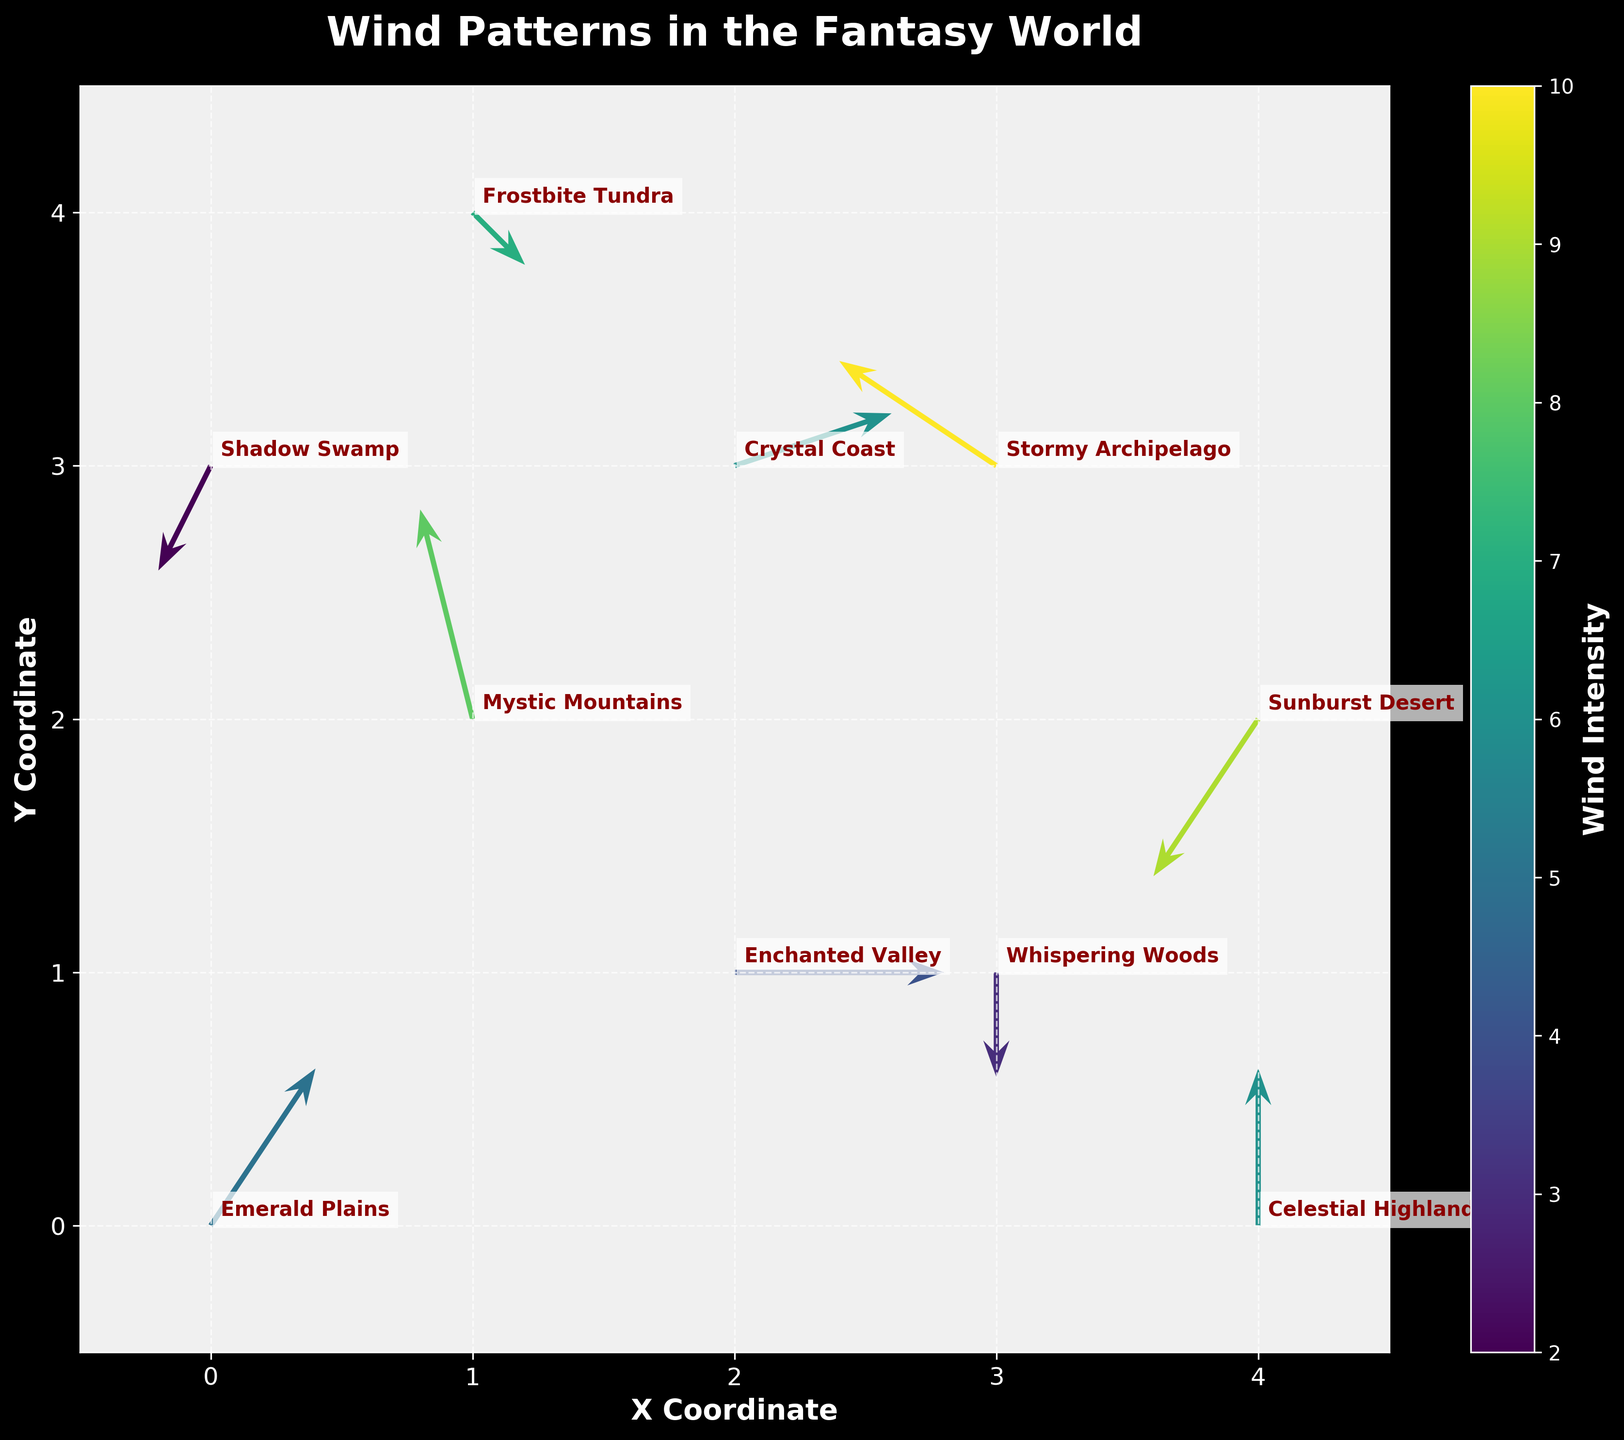Which region shows the highest wind intensity? The region with the highest wind intensity is indicated by the darkest color on the quiver plot. By observing the color gradient, Stormy Archipelago has the highest intensity of 10.
Answer: Stormy Archipelago How many data points are plotted in total? Counting the quivers on the plot, there are 10 data points representing the regions listed in the provided data.
Answer: 10 Which region has the wind direction going directly downward? The wind direction going directly downward is represented by a quiver with a vertical component (v) and no horizontal component (u). Whispering Woods has this characteristic with (0, -2).
Answer: Whispering Woods What is the average wind intensity across all regions? By summing the wind intensities (5 + 8 + 3 + 6 + 9 + 7 + 10 + 4 + 6 + 2) and then dividing by the number of regions (10), the average intensity is calculated as (60 / 10) = 6.
Answer: 6 Which regions have wind intensities greater than 6? By examining the color bar and region labels, the regions with wind intensities greater than 6 are Mystic Mountains (8), Sunburst Desert (9), Frostbite Tundra (7), and Stormy Archipelago (10).
Answer: Mystic Mountains, Sunburst Desert, Frostbite Tundra, Stormy Archipelago Is the wind direction in Enchanted Valley pointing horizontally? For horizontal direction, u should be non-zero and v should be zero, which matches Enchanted Valley's values of (4, 0). Thus, the wind direction is horizontal.
Answer: Yes What is the difference in wind intensity between Mystic Mountains and Shadow Swamp? Mystic Mountains has an intensity of 8, while Shadow Swamp has an intensity of 2. The difference is calculated as (8 - 2) = 6.
Answer: 6 Which region has wind moving in a north-east direction? North-east direction indicates positive values for both u and v components. Crystal Coast with (3, 1) has wind moving in this direction.
Answer: Crystal Coast Compare the wind intensity between Emerald Plains and Celestial Highlands. Which is greater? The wind intensity of Emerald Plains is 5, while Celestial Highlands has an intensity of 6. So, Celestial Highlands has a greater wind intensity.
Answer: Celestial Highlands Which regions are positioned at coordinates where x=3? By looking at the plot and the given coordinate data, Whispering Woods (3,1) and Stormy Archipelago (3,3) are positioned at x=3.
Answer: Whispering Woods, Stormy Archipelago 